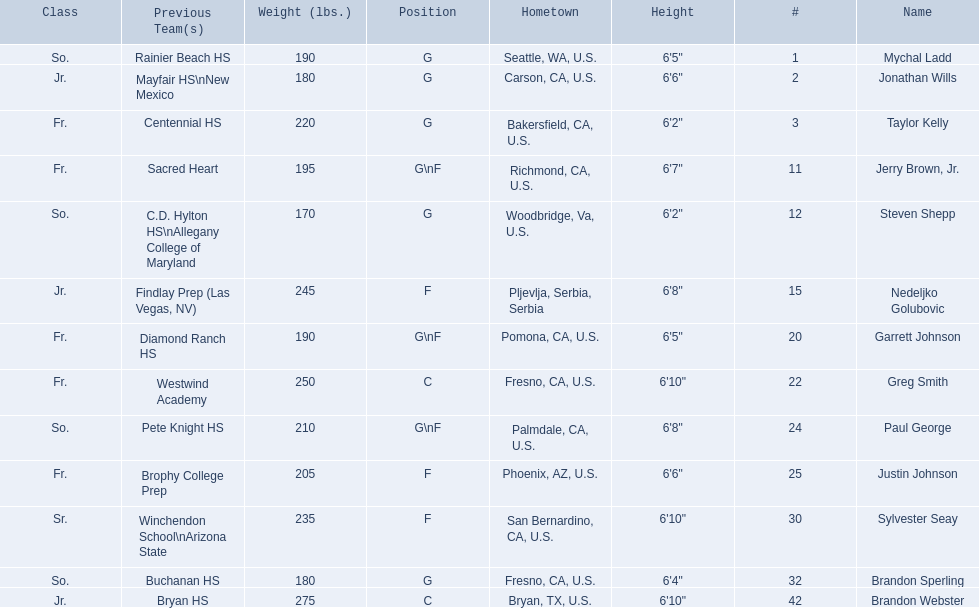What are the names for all players? Mychal Ladd, Jonathan Wills, Taylor Kelly, Jerry Brown, Jr., Steven Shepp, Nedeljko Golubovic, Garrett Johnson, Greg Smith, Paul George, Justin Johnson, Sylvester Seay, Brandon Sperling, Brandon Webster. Which players are taller than 6'8? Nedeljko Golubovic, Greg Smith, Paul George, Sylvester Seay, Brandon Webster. How tall is paul george? 6'8". How tall is greg smith? 6'10". Of these two, which it tallest? Greg Smith. 